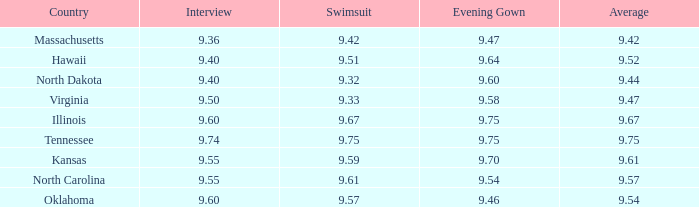What was the average for the country with the swimsuit score of 9.57? 9.54. 